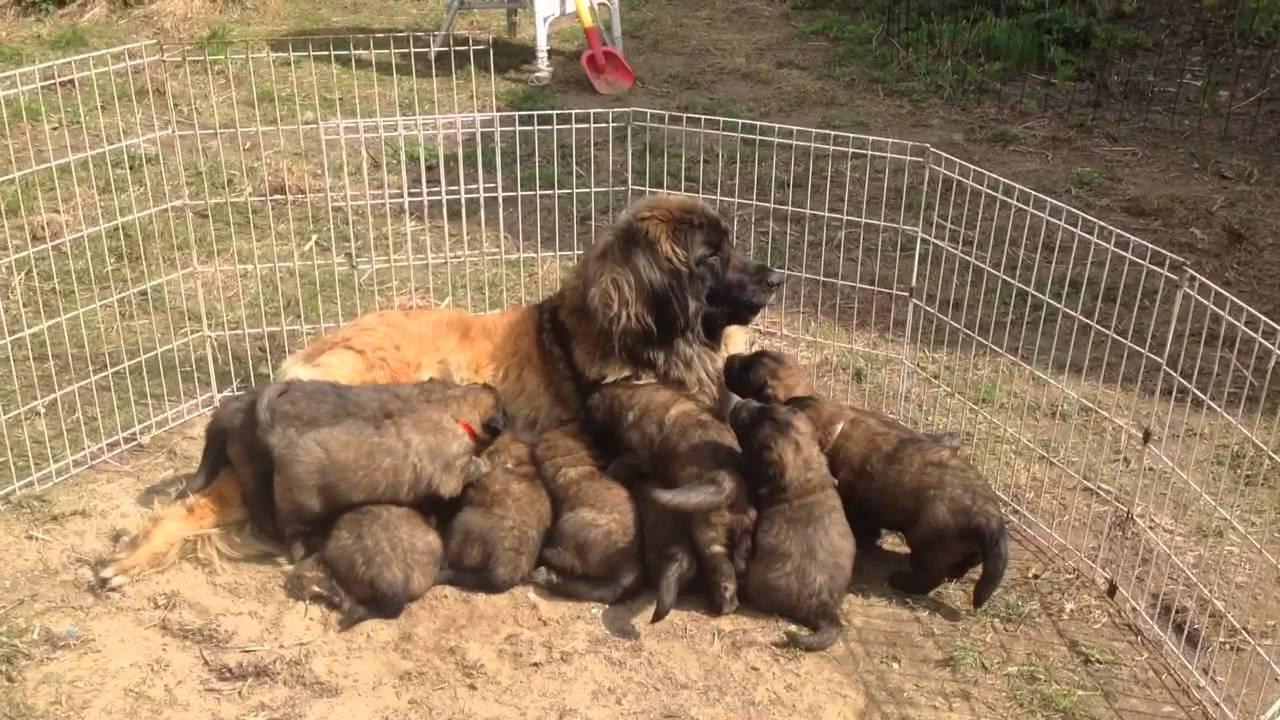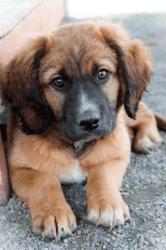The first image is the image on the left, the second image is the image on the right. For the images shown, is this caption "The dog on the right is nursing a pile of brown puppies, while the dog on the left is all alone, and an image shows a wood frame forming a corner around a dog." true? Answer yes or no. No. The first image is the image on the left, the second image is the image on the right. Given the left and right images, does the statement "An adult dog is lying on her side with front legs extended outward while her puppies crowd in to nurse, while a second image shows a large dog lying on a floor." hold true? Answer yes or no. No. 